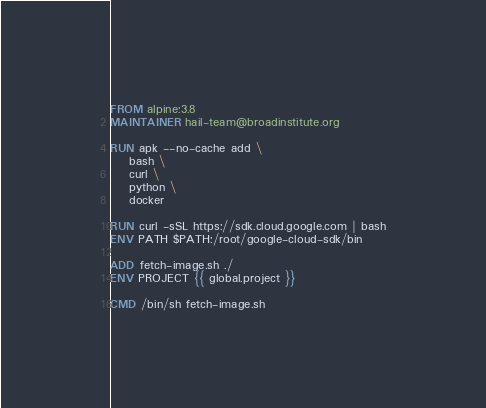Convert code to text. <code><loc_0><loc_0><loc_500><loc_500><_Dockerfile_>FROM alpine:3.8
MAINTAINER hail-team@broadinstitute.org

RUN apk --no-cache add \
    bash \
    curl \
    python \
    docker

RUN curl -sSL https://sdk.cloud.google.com | bash
ENV PATH $PATH:/root/google-cloud-sdk/bin

ADD fetch-image.sh ./
ENV PROJECT {{ global.project }}

CMD /bin/sh fetch-image.sh
</code> 